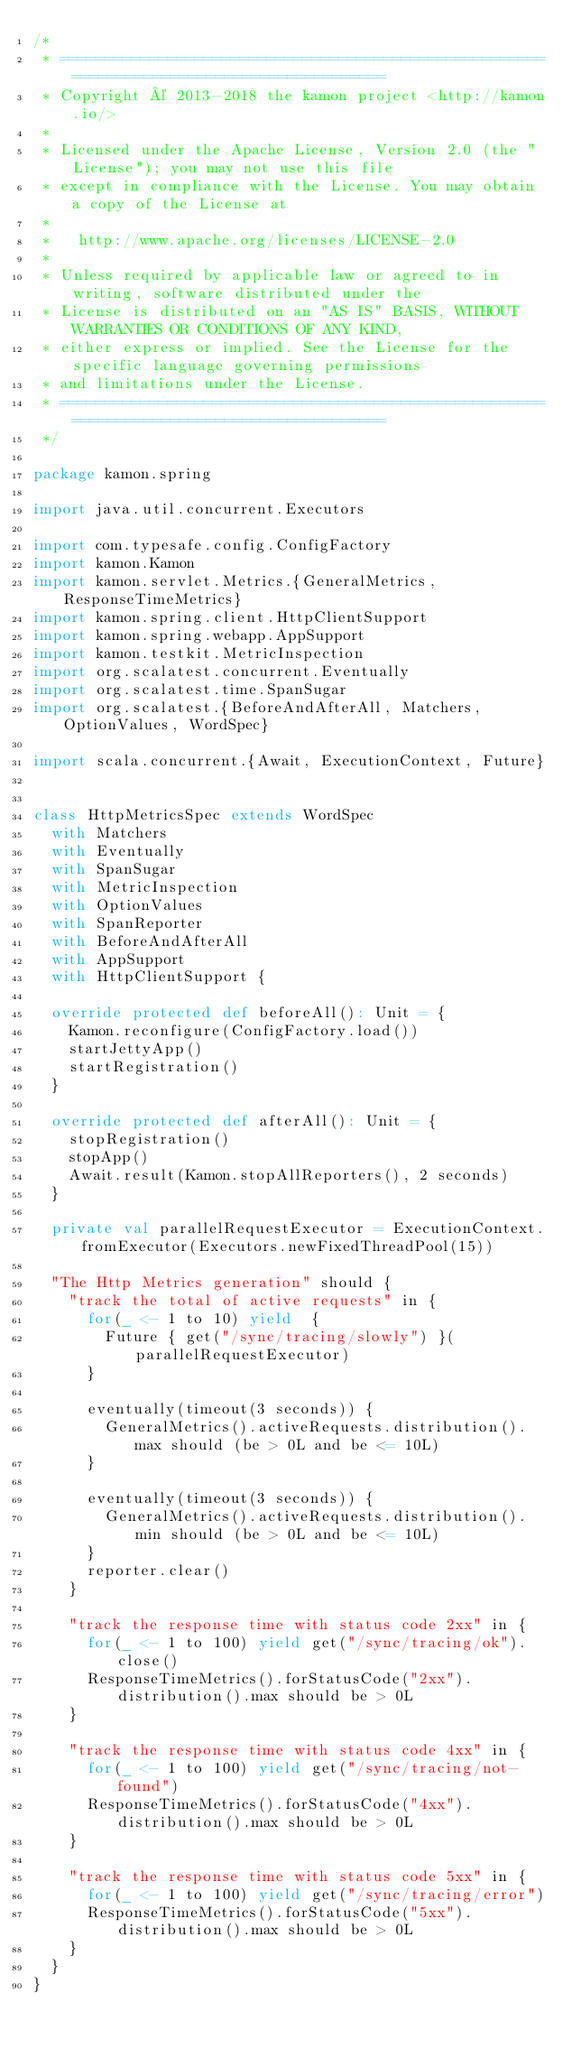Convert code to text. <code><loc_0><loc_0><loc_500><loc_500><_Scala_>/*
 * =========================================================================================
 * Copyright © 2013-2018 the kamon project <http://kamon.io/>
 *
 * Licensed under the Apache License, Version 2.0 (the "License"); you may not use this file
 * except in compliance with the License. You may obtain a copy of the License at
 *
 *   http://www.apache.org/licenses/LICENSE-2.0
 *
 * Unless required by applicable law or agreed to in writing, software distributed under the
 * License is distributed on an "AS IS" BASIS, WITHOUT WARRANTIES OR CONDITIONS OF ANY KIND,
 * either express or implied. See the License for the specific language governing permissions
 * and limitations under the License.
 * =========================================================================================
 */

package kamon.spring

import java.util.concurrent.Executors

import com.typesafe.config.ConfigFactory
import kamon.Kamon
import kamon.servlet.Metrics.{GeneralMetrics, ResponseTimeMetrics}
import kamon.spring.client.HttpClientSupport
import kamon.spring.webapp.AppSupport
import kamon.testkit.MetricInspection
import org.scalatest.concurrent.Eventually
import org.scalatest.time.SpanSugar
import org.scalatest.{BeforeAndAfterAll, Matchers, OptionValues, WordSpec}

import scala.concurrent.{Await, ExecutionContext, Future}


class HttpMetricsSpec extends WordSpec
  with Matchers
  with Eventually
  with SpanSugar
  with MetricInspection
  with OptionValues
  with SpanReporter
  with BeforeAndAfterAll
  with AppSupport
  with HttpClientSupport {

  override protected def beforeAll(): Unit = {
    Kamon.reconfigure(ConfigFactory.load())
    startJettyApp()
    startRegistration()
  }

  override protected def afterAll(): Unit = {
    stopRegistration()
    stopApp()
    Await.result(Kamon.stopAllReporters(), 2 seconds)
  }

  private val parallelRequestExecutor = ExecutionContext.fromExecutor(Executors.newFixedThreadPool(15))

  "The Http Metrics generation" should {
    "track the total of active requests" in {
      for(_ <- 1 to 10) yield  {
        Future { get("/sync/tracing/slowly") }(parallelRequestExecutor)
      }

      eventually(timeout(3 seconds)) {
        GeneralMetrics().activeRequests.distribution().max should (be > 0L and be <= 10L)
      }

      eventually(timeout(3 seconds)) {
        GeneralMetrics().activeRequests.distribution().min should (be > 0L and be <= 10L)
      }
      reporter.clear()
    }

    "track the response time with status code 2xx" in {
      for(_ <- 1 to 100) yield get("/sync/tracing/ok").close()
      ResponseTimeMetrics().forStatusCode("2xx").distribution().max should be > 0L
    }

    "track the response time with status code 4xx" in {
      for(_ <- 1 to 100) yield get("/sync/tracing/not-found")
      ResponseTimeMetrics().forStatusCode("4xx").distribution().max should be > 0L
    }

    "track the response time with status code 5xx" in {
      for(_ <- 1 to 100) yield get("/sync/tracing/error")
      ResponseTimeMetrics().forStatusCode("5xx").distribution().max should be > 0L
    }
  }
}
</code> 